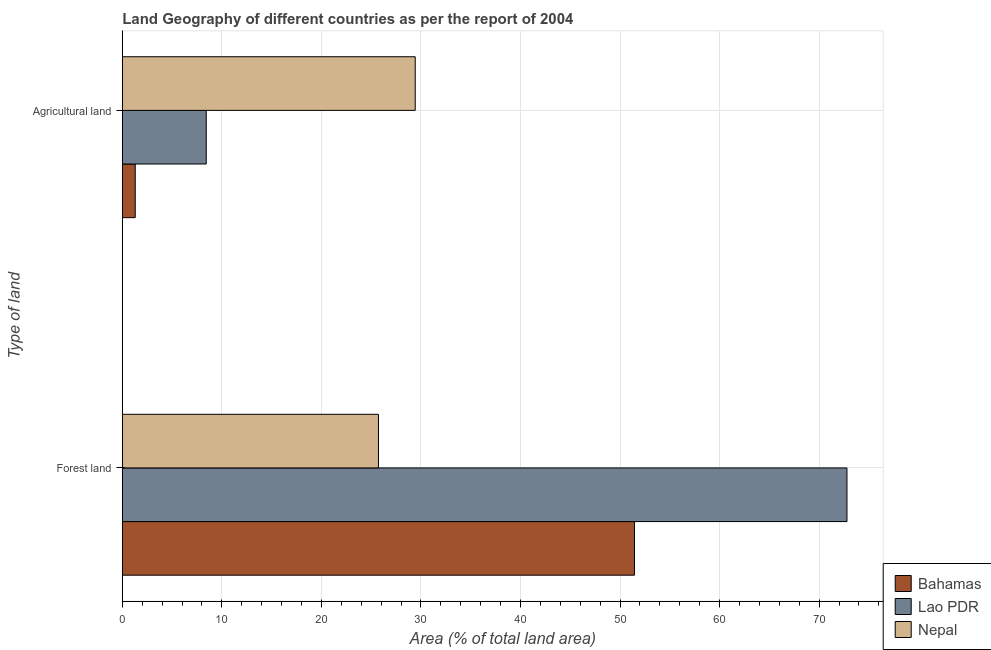How many bars are there on the 1st tick from the top?
Provide a short and direct response. 3. What is the label of the 1st group of bars from the top?
Provide a short and direct response. Agricultural land. What is the percentage of land area under forests in Nepal?
Provide a succinct answer. 25.73. Across all countries, what is the maximum percentage of land area under agriculture?
Your answer should be compact. 29.42. Across all countries, what is the minimum percentage of land area under forests?
Your answer should be very brief. 25.73. In which country was the percentage of land area under forests maximum?
Your response must be concise. Lao PDR. In which country was the percentage of land area under forests minimum?
Offer a terse response. Nepal. What is the total percentage of land area under agriculture in the graph?
Your answer should be very brief. 39.15. What is the difference between the percentage of land area under agriculture in Lao PDR and that in Nepal?
Make the answer very short. -20.99. What is the difference between the percentage of land area under agriculture in Bahamas and the percentage of land area under forests in Lao PDR?
Provide a succinct answer. -71.5. What is the average percentage of land area under agriculture per country?
Offer a terse response. 13.05. What is the difference between the percentage of land area under agriculture and percentage of land area under forests in Nepal?
Offer a very short reply. 3.69. In how many countries, is the percentage of land area under agriculture greater than 62 %?
Offer a terse response. 0. What is the ratio of the percentage of land area under forests in Lao PDR to that in Nepal?
Your response must be concise. 2.83. In how many countries, is the percentage of land area under forests greater than the average percentage of land area under forests taken over all countries?
Offer a terse response. 2. What does the 1st bar from the top in Agricultural land represents?
Offer a very short reply. Nepal. What does the 3rd bar from the bottom in Forest land represents?
Give a very brief answer. Nepal. Are all the bars in the graph horizontal?
Make the answer very short. Yes. How many countries are there in the graph?
Your answer should be very brief. 3. What is the difference between two consecutive major ticks on the X-axis?
Make the answer very short. 10. Does the graph contain any zero values?
Your answer should be very brief. No. Where does the legend appear in the graph?
Offer a terse response. Bottom right. What is the title of the graph?
Your answer should be compact. Land Geography of different countries as per the report of 2004. Does "Botswana" appear as one of the legend labels in the graph?
Offer a terse response. No. What is the label or title of the X-axis?
Your answer should be very brief. Area (% of total land area). What is the label or title of the Y-axis?
Your answer should be very brief. Type of land. What is the Area (% of total land area) in Bahamas in Forest land?
Your answer should be very brief. 51.45. What is the Area (% of total land area) of Lao PDR in Forest land?
Your answer should be very brief. 72.79. What is the Area (% of total land area) of Nepal in Forest land?
Ensure brevity in your answer.  25.73. What is the Area (% of total land area) of Bahamas in Agricultural land?
Keep it short and to the point. 1.3. What is the Area (% of total land area) in Lao PDR in Agricultural land?
Make the answer very short. 8.43. What is the Area (% of total land area) of Nepal in Agricultural land?
Provide a short and direct response. 29.42. Across all Type of land, what is the maximum Area (% of total land area) of Bahamas?
Offer a terse response. 51.45. Across all Type of land, what is the maximum Area (% of total land area) in Lao PDR?
Give a very brief answer. 72.79. Across all Type of land, what is the maximum Area (% of total land area) of Nepal?
Offer a very short reply. 29.42. Across all Type of land, what is the minimum Area (% of total land area) of Bahamas?
Provide a short and direct response. 1.3. Across all Type of land, what is the minimum Area (% of total land area) in Lao PDR?
Provide a short and direct response. 8.43. Across all Type of land, what is the minimum Area (% of total land area) in Nepal?
Give a very brief answer. 25.73. What is the total Area (% of total land area) of Bahamas in the graph?
Offer a very short reply. 52.75. What is the total Area (% of total land area) of Lao PDR in the graph?
Provide a succinct answer. 81.23. What is the total Area (% of total land area) of Nepal in the graph?
Keep it short and to the point. 55.16. What is the difference between the Area (% of total land area) of Bahamas in Forest land and that in Agricultural land?
Offer a terse response. 50.15. What is the difference between the Area (% of total land area) in Lao PDR in Forest land and that in Agricultural land?
Offer a terse response. 64.36. What is the difference between the Area (% of total land area) of Nepal in Forest land and that in Agricultural land?
Your answer should be very brief. -3.69. What is the difference between the Area (% of total land area) in Bahamas in Forest land and the Area (% of total land area) in Lao PDR in Agricultural land?
Your answer should be very brief. 43.02. What is the difference between the Area (% of total land area) of Bahamas in Forest land and the Area (% of total land area) of Nepal in Agricultural land?
Your response must be concise. 22.02. What is the difference between the Area (% of total land area) of Lao PDR in Forest land and the Area (% of total land area) of Nepal in Agricultural land?
Give a very brief answer. 43.37. What is the average Area (% of total land area) in Bahamas per Type of land?
Give a very brief answer. 26.37. What is the average Area (% of total land area) of Lao PDR per Type of land?
Your answer should be very brief. 40.61. What is the average Area (% of total land area) in Nepal per Type of land?
Offer a terse response. 27.58. What is the difference between the Area (% of total land area) in Bahamas and Area (% of total land area) in Lao PDR in Forest land?
Provide a succinct answer. -21.35. What is the difference between the Area (% of total land area) of Bahamas and Area (% of total land area) of Nepal in Forest land?
Make the answer very short. 25.72. What is the difference between the Area (% of total land area) of Lao PDR and Area (% of total land area) of Nepal in Forest land?
Ensure brevity in your answer.  47.06. What is the difference between the Area (% of total land area) in Bahamas and Area (% of total land area) in Lao PDR in Agricultural land?
Give a very brief answer. -7.13. What is the difference between the Area (% of total land area) in Bahamas and Area (% of total land area) in Nepal in Agricultural land?
Provide a succinct answer. -28.13. What is the difference between the Area (% of total land area) in Lao PDR and Area (% of total land area) in Nepal in Agricultural land?
Your answer should be very brief. -20.99. What is the ratio of the Area (% of total land area) of Bahamas in Forest land to that in Agricultural land?
Your answer should be compact. 39.62. What is the ratio of the Area (% of total land area) in Lao PDR in Forest land to that in Agricultural land?
Provide a short and direct response. 8.63. What is the ratio of the Area (% of total land area) of Nepal in Forest land to that in Agricultural land?
Provide a succinct answer. 0.87. What is the difference between the highest and the second highest Area (% of total land area) in Bahamas?
Your answer should be compact. 50.15. What is the difference between the highest and the second highest Area (% of total land area) in Lao PDR?
Offer a very short reply. 64.36. What is the difference between the highest and the second highest Area (% of total land area) in Nepal?
Give a very brief answer. 3.69. What is the difference between the highest and the lowest Area (% of total land area) of Bahamas?
Ensure brevity in your answer.  50.15. What is the difference between the highest and the lowest Area (% of total land area) in Lao PDR?
Provide a short and direct response. 64.36. What is the difference between the highest and the lowest Area (% of total land area) in Nepal?
Your response must be concise. 3.69. 